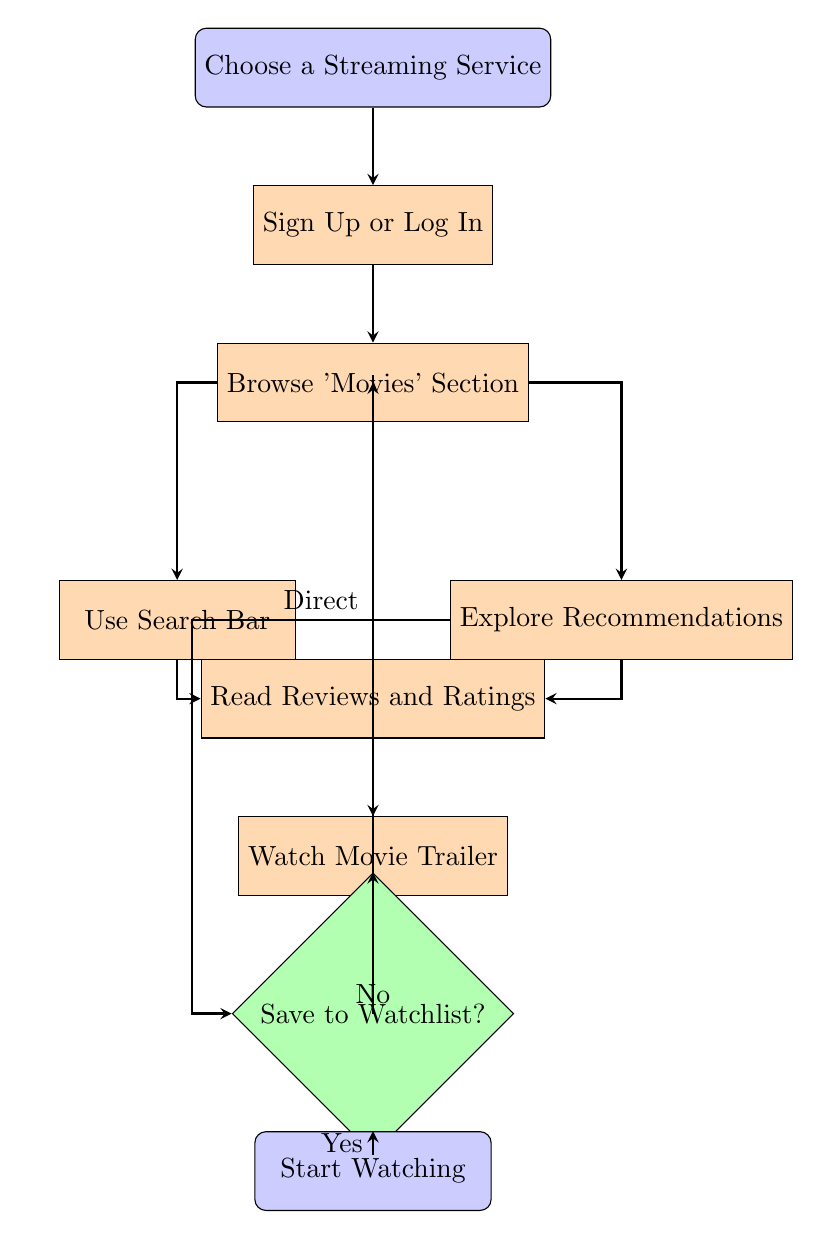What is the first step in the flow chart? The first step in the flow chart is "Choose a Streaming Service," which is the starting node before any other actions are taken.
Answer: Choose a Streaming Service How many nodes are there in total? By counting all unique actions and decisions outlined in the flow chart, there are nine distinct nodes detailing the process from start to finish.
Answer: Nine What action follows 'Sign Up or Log In'? After 'Sign Up or Log In', the next action is 'Browse Movies Section', where the user selects movies after logging into the streaming service.
Answer: Browse Movies Section From which node can you directly access the 'Read Reviews and Ratings' action? There are two nodes that directly lead to 'Read Reviews and Ratings': 'Use Search Bar' and 'Explore Recommendations'. This indicates that users can come to this stage from either of those two nodes.
Answer: Use Search Bar, Explore Recommendations If a user does not save a movie to their watchlist, which node do they return to? If a user chooses not to save a movie to their watchlist, they will return to 'Browse Movies Section', allowing them to continue exploring more movie options.
Answer: Browse Movies Section How many possible paths lead to 'Watch Movie Trailer'? There are two different paths leading to 'Watch Movie Trailer': one from 'Read Reviews and Ratings' and another from both 'Use Search Bar' and 'Explore Recommendations'. Thus, there are two direct paths.
Answer: Two What is the final action in the flow chart? The final action in the flow chart is 'Start Watching', which indicates the culmination of the process of finding and selecting a movie.
Answer: Start Watching Which node allows users to make personalized movie choices? The node 'Explore Recommendations' allows users to see tailored suggestions based on their past viewing habits, enabling more personalized movie choices.
Answer: Explore Recommendations What decision must a user make after watching the trailer? After watching the trailer, the user must decide whether to save the movie to their watchlist, which determines the next step in the flow.
Answer: Save to Watchlist? 